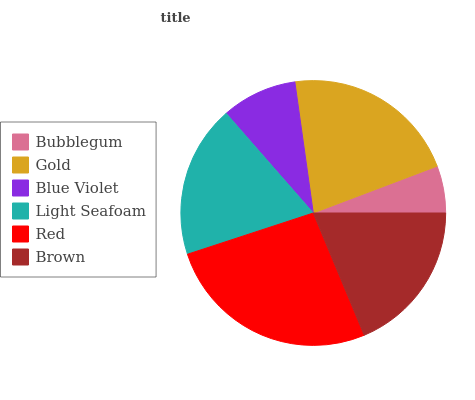Is Bubblegum the minimum?
Answer yes or no. Yes. Is Red the maximum?
Answer yes or no. Yes. Is Gold the minimum?
Answer yes or no. No. Is Gold the maximum?
Answer yes or no. No. Is Gold greater than Bubblegum?
Answer yes or no. Yes. Is Bubblegum less than Gold?
Answer yes or no. Yes. Is Bubblegum greater than Gold?
Answer yes or no. No. Is Gold less than Bubblegum?
Answer yes or no. No. Is Brown the high median?
Answer yes or no. Yes. Is Light Seafoam the low median?
Answer yes or no. Yes. Is Blue Violet the high median?
Answer yes or no. No. Is Blue Violet the low median?
Answer yes or no. No. 